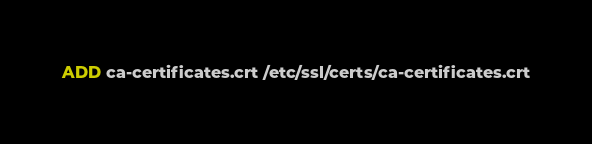Convert code to text. <code><loc_0><loc_0><loc_500><loc_500><_Dockerfile_>ADD ca-certificates.crt /etc/ssl/certs/ca-certificates.crt

</code> 